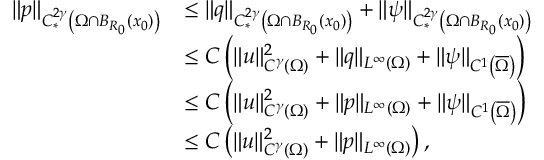Convert formula to latex. <formula><loc_0><loc_0><loc_500><loc_500>\begin{array} { r l } { \| p \| _ { C _ { * } ^ { 2 \gamma } \left ( \Omega \cap B _ { R _ { 0 } } ( x _ { 0 } ) \right ) } } & { \leq \| q \| _ { C _ { * } ^ { 2 \gamma } \left ( \Omega \cap B _ { R _ { 0 } } ( x _ { 0 } ) \right ) } + \| \psi \| _ { C _ { * } ^ { 2 \gamma } \left ( \Omega \cap B _ { R _ { 0 } } ( x _ { 0 } ) \right ) } } \\ & { \leq C \left ( \| u \| _ { C ^ { \gamma } ( \Omega ) } ^ { 2 } + \| q \| _ { L ^ { \infty } ( \Omega ) } + \| \psi \| _ { C ^ { 1 } \left ( \overline { \Omega } \right ) } \right ) } \\ & { \leq C \left ( \| u \| _ { C ^ { \gamma } ( \Omega ) } ^ { 2 } + \| p \| _ { L ^ { \infty } ( \Omega ) } + \| \psi \| _ { C ^ { 1 } \left ( \overline { \Omega } \right ) } \right ) } \\ & { \leq C \left ( \| u \| _ { C ^ { \gamma } ( \Omega ) } ^ { 2 } + \| p \| _ { L ^ { \infty } ( \Omega ) } \right ) , } \end{array}</formula> 